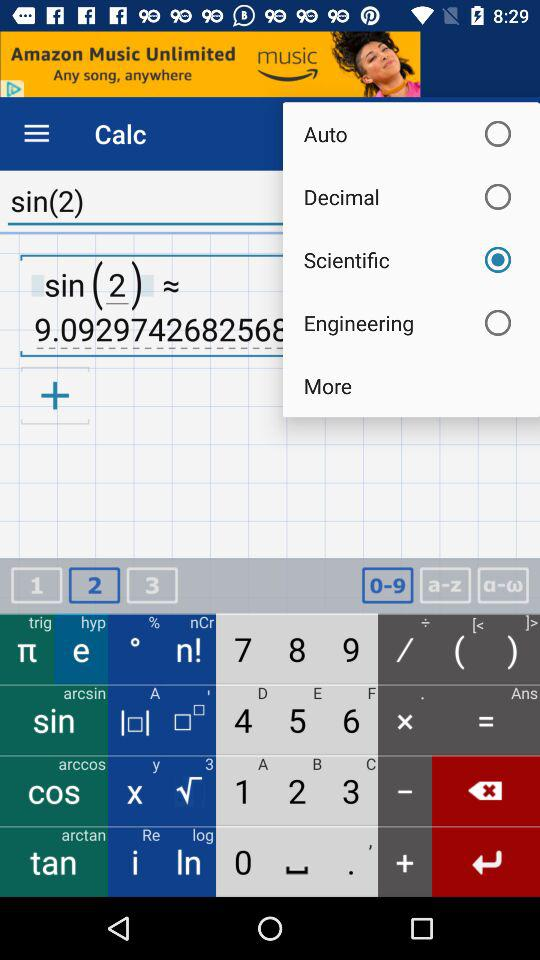What is the result of the calculation?
Answer the question using a single word or phrase. 9.0929742682568 